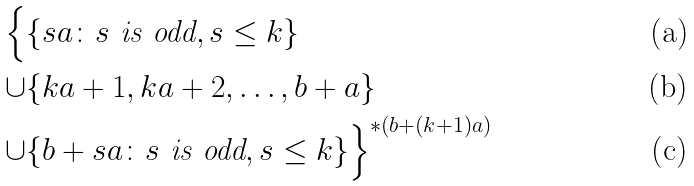Convert formula to latex. <formula><loc_0><loc_0><loc_500><loc_500>\Big { \{ } & \{ s a \colon s \text { is odd} , s \leq k \} \\ \cup & \{ k a + 1 , k a + 2 , \dots , b + a \} \\ \cup & \{ b + s a \colon s \text { is odd} , s \leq k \} \Big { \} } ^ { * ( b + ( k + 1 ) a ) }</formula> 